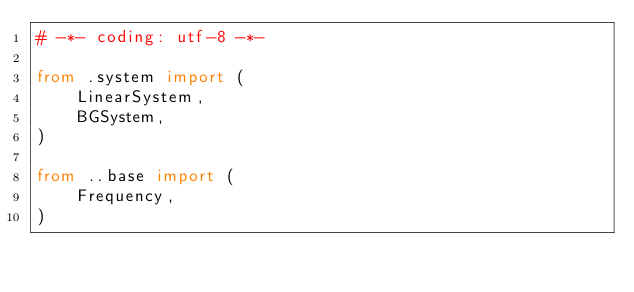<code> <loc_0><loc_0><loc_500><loc_500><_Python_># -*- coding: utf-8 -*-

from .system import (
    LinearSystem,
    BGSystem,
)

from ..base import (
    Frequency,
)

</code> 